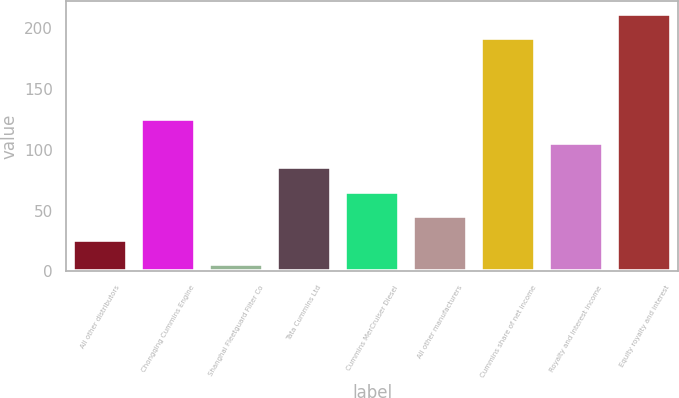<chart> <loc_0><loc_0><loc_500><loc_500><bar_chart><fcel>All other distributors<fcel>Chongqing Cummins Engine<fcel>Shanghai Fleetguard Filter Co<fcel>Tata Cummins Ltd<fcel>Cummins MerCruiser Diesel<fcel>All other manufacturers<fcel>Cummins share of net income<fcel>Royalty and interest income<fcel>Equity royalty and interest<nl><fcel>25.9<fcel>125.4<fcel>6<fcel>85.6<fcel>65.7<fcel>45.8<fcel>192<fcel>105.5<fcel>211.9<nl></chart> 